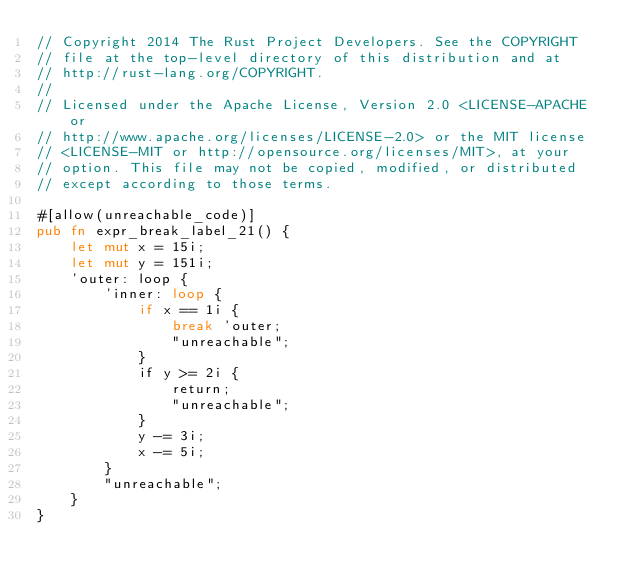<code> <loc_0><loc_0><loc_500><loc_500><_Rust_>// Copyright 2014 The Rust Project Developers. See the COPYRIGHT
// file at the top-level directory of this distribution and at
// http://rust-lang.org/COPYRIGHT.
//
// Licensed under the Apache License, Version 2.0 <LICENSE-APACHE or
// http://www.apache.org/licenses/LICENSE-2.0> or the MIT license
// <LICENSE-MIT or http://opensource.org/licenses/MIT>, at your
// option. This file may not be copied, modified, or distributed
// except according to those terms.

#[allow(unreachable_code)]
pub fn expr_break_label_21() {
    let mut x = 15i;
    let mut y = 151i;
    'outer: loop {
        'inner: loop {
            if x == 1i {
                break 'outer;
                "unreachable";
            }
            if y >= 2i {
                return;
                "unreachable";
            }
            y -= 3i;
            x -= 5i;
        }
        "unreachable";
    }
}
</code> 